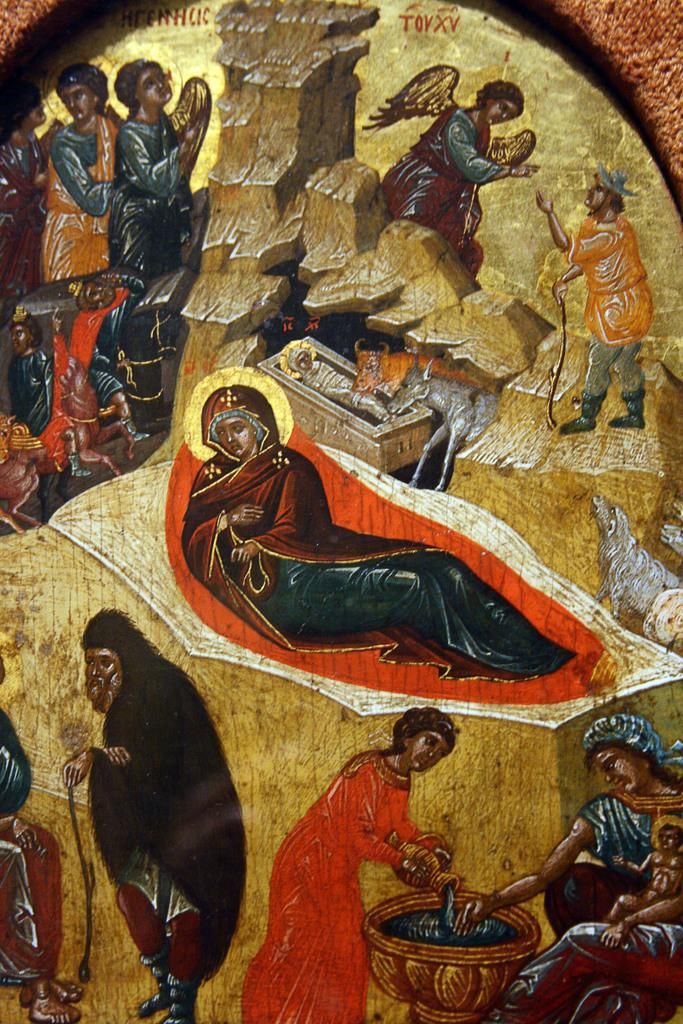What types of subjects can be seen in the painting? There are people and animals in the painting. What other elements are present in the painting? There are stones, vessels, and other objects in the painting. Is there any text in the painting? Yes, there is text at the top of the painting. What type of shoe is depicted in the painting? There is no shoe present in the painting; it features people, animals, stones, vessels, other objects, and text. 